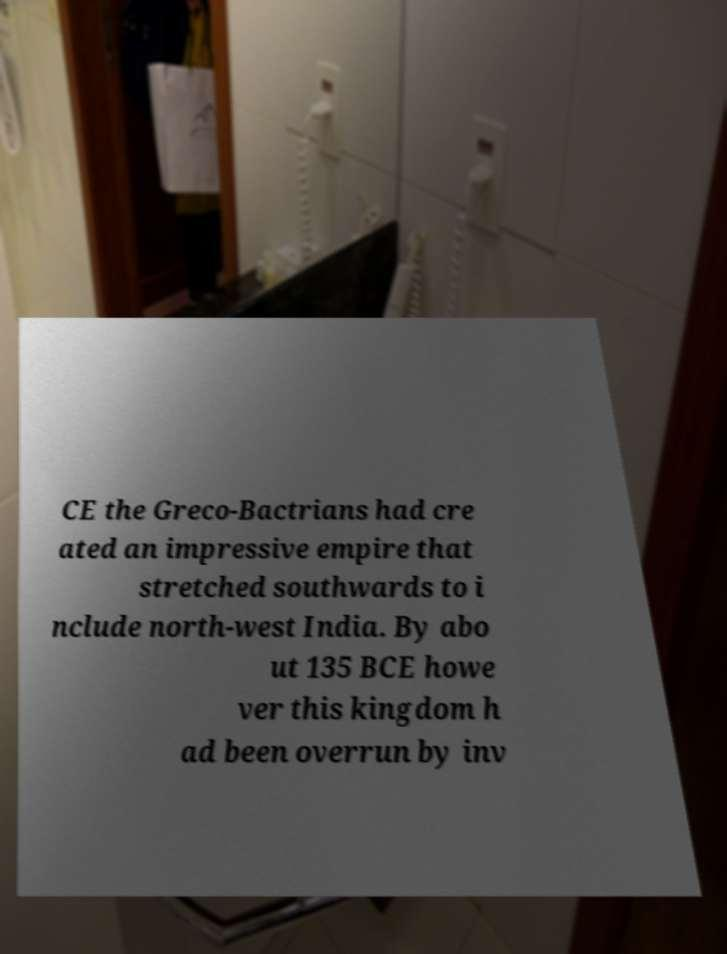There's text embedded in this image that I need extracted. Can you transcribe it verbatim? CE the Greco-Bactrians had cre ated an impressive empire that stretched southwards to i nclude north-west India. By abo ut 135 BCE howe ver this kingdom h ad been overrun by inv 